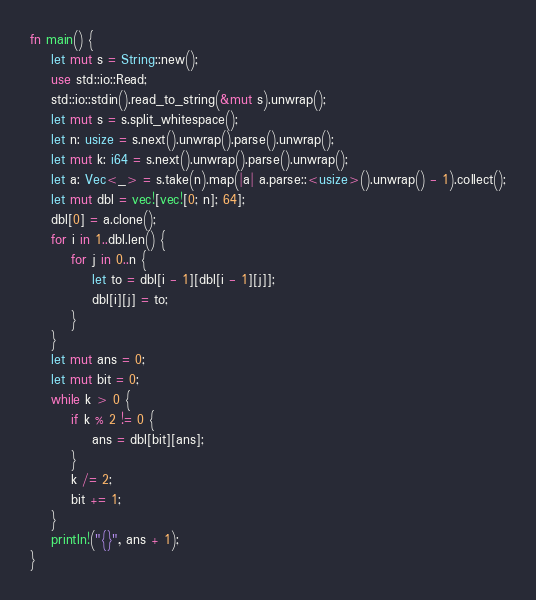<code> <loc_0><loc_0><loc_500><loc_500><_Rust_>fn main() {
	let mut s = String::new();
	use std::io::Read;
	std::io::stdin().read_to_string(&mut s).unwrap();
	let mut s = s.split_whitespace();
	let n: usize = s.next().unwrap().parse().unwrap();
	let mut k: i64 = s.next().unwrap().parse().unwrap();
	let a: Vec<_> = s.take(n).map(|a| a.parse::<usize>().unwrap() - 1).collect();
	let mut dbl = vec![vec![0; n]; 64];
	dbl[0] = a.clone();
	for i in 1..dbl.len() {
		for j in 0..n {
			let to = dbl[i - 1][dbl[i - 1][j]];
			dbl[i][j] = to;
		}
	}
	let mut ans = 0;
	let mut bit = 0;
	while k > 0 {
		if k % 2 != 0 {
			ans = dbl[bit][ans];
		}
		k /= 2;
		bit += 1;
	}
	println!("{}", ans + 1);
}
</code> 